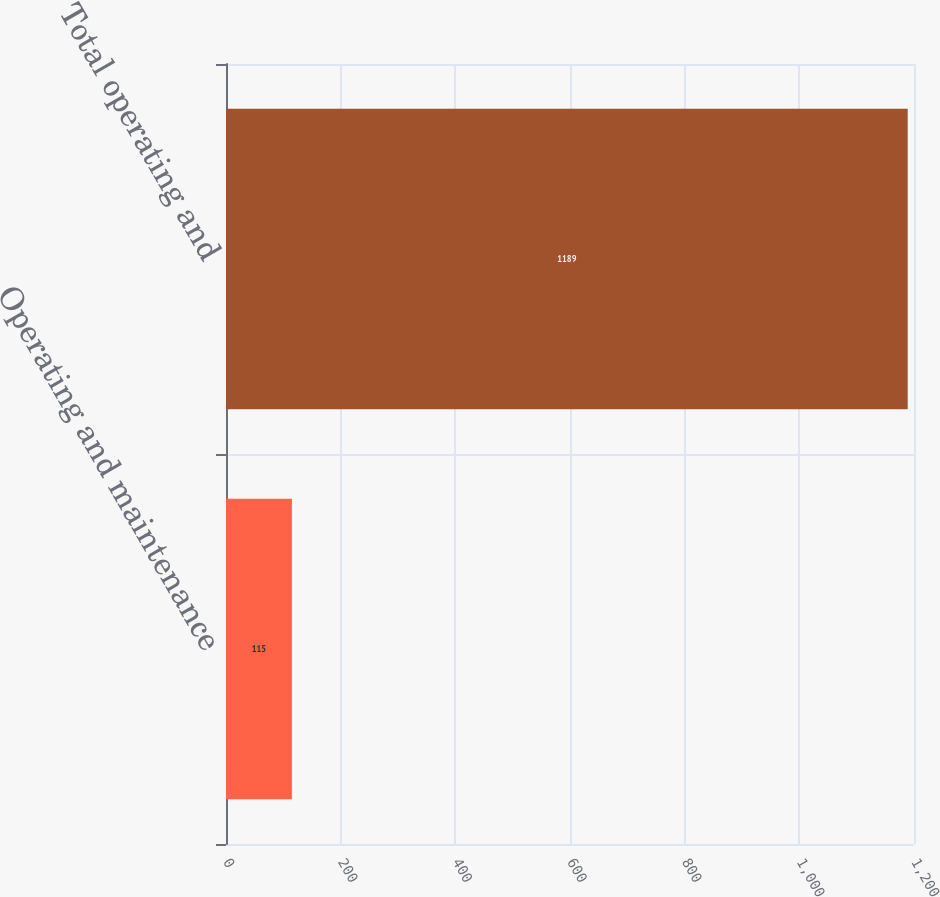Convert chart. <chart><loc_0><loc_0><loc_500><loc_500><bar_chart><fcel>Operating and maintenance<fcel>Total operating and<nl><fcel>115<fcel>1189<nl></chart> 